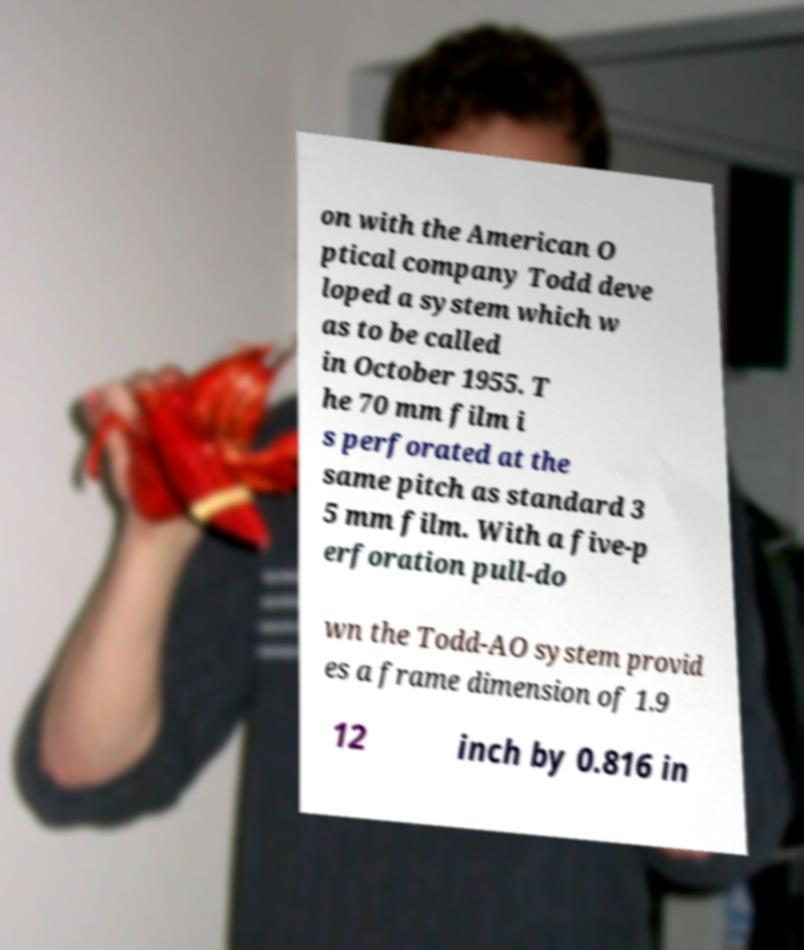Can you accurately transcribe the text from the provided image for me? on with the American O ptical company Todd deve loped a system which w as to be called in October 1955. T he 70 mm film i s perforated at the same pitch as standard 3 5 mm film. With a five-p erforation pull-do wn the Todd-AO system provid es a frame dimension of 1.9 12 inch by 0.816 in 